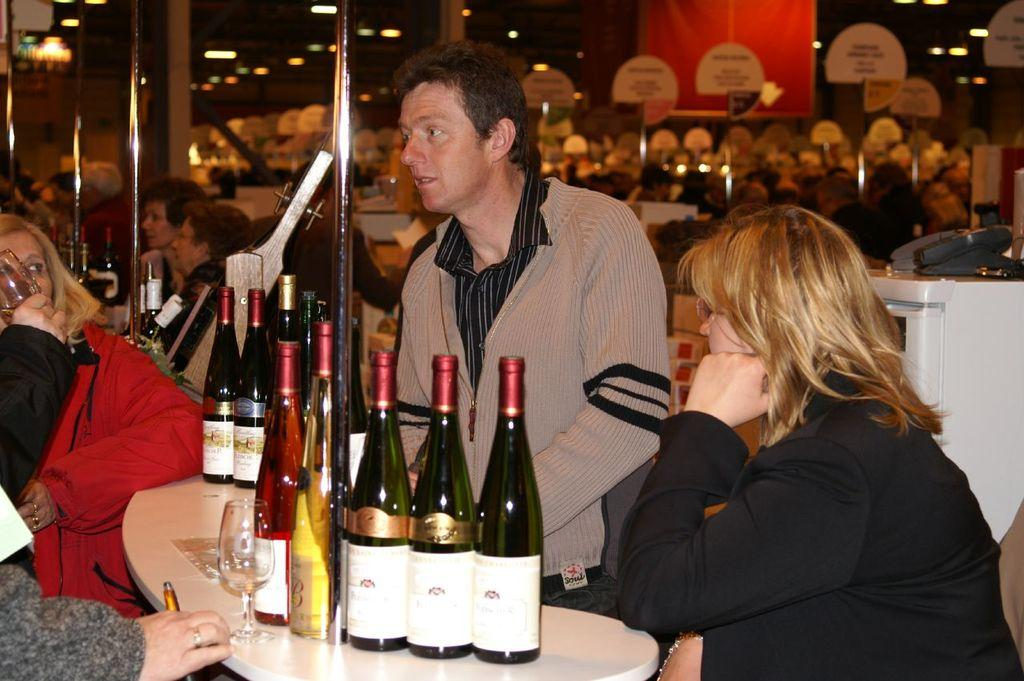Where was the image taken? The image was taken inside a restaurant. What is happening around the table in the image? People are standing on both sides of the table. What items can be seen on the table? Wine bottles and glasses are present on the table. How many babies are crawling under the table in the image? There are no babies present in the image, and therefore no crawling babies can be observed. 